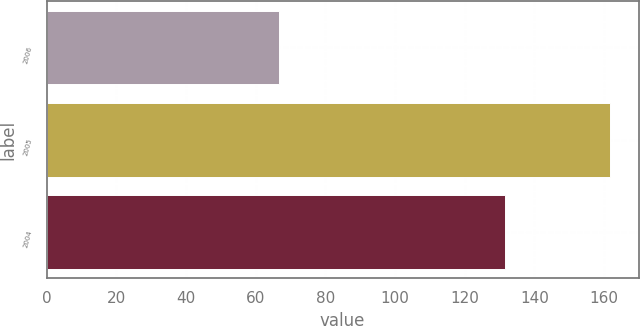<chart> <loc_0><loc_0><loc_500><loc_500><bar_chart><fcel>2006<fcel>2005<fcel>2004<nl><fcel>66.8<fcel>161.8<fcel>131.6<nl></chart> 